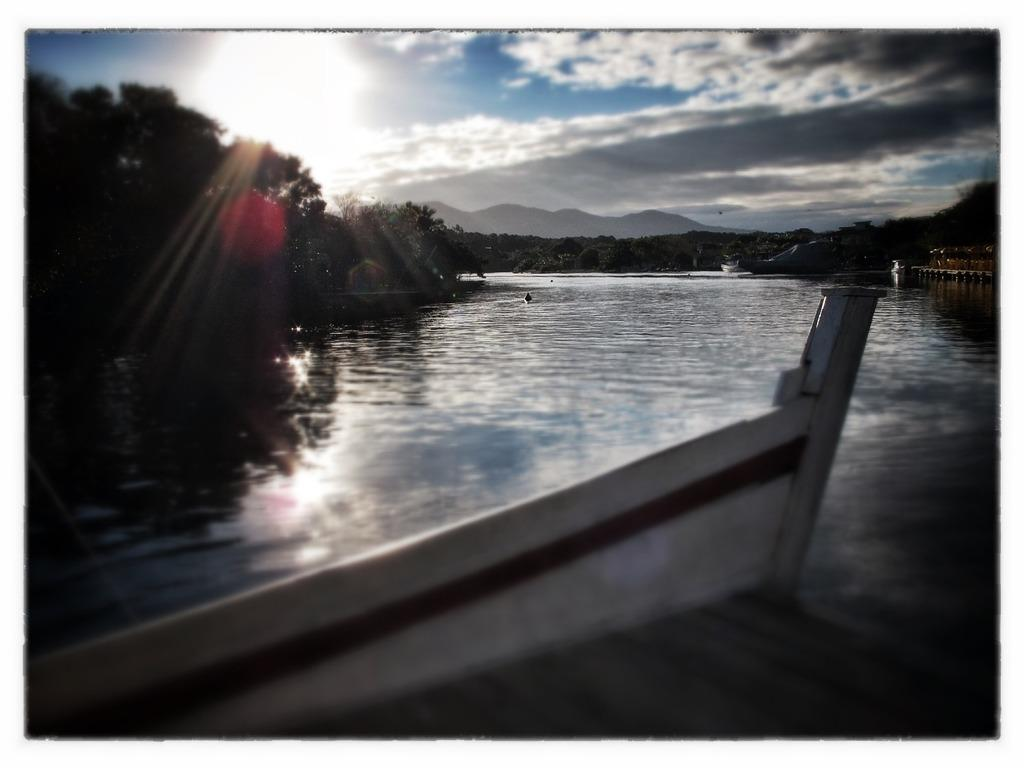What structure can be seen at the bottom of the image? There is a dock at the bottom of the image. What type of vegetation is visible in the image? Trees are visible in the image. What geographical feature is present in the background of the image? Mountains are present in the image. What body of water is featured in the image? A lake is in the image. How would you describe the sky in the image? The sky is blue with clouds. What type of rock is being requested by the person in the image? There is no person present in the image, and therefore no request for a rock can be observed. What class is being taught in the image? There is no indication of a class or teaching activity in the image. 